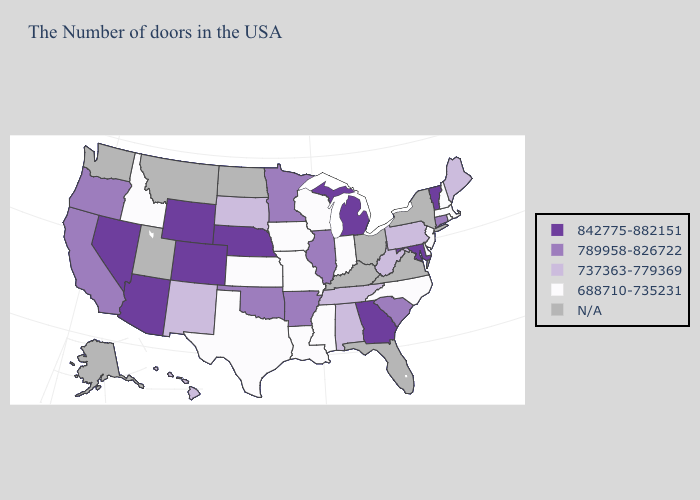What is the highest value in the USA?
Write a very short answer. 842775-882151. Is the legend a continuous bar?
Write a very short answer. No. Does Indiana have the highest value in the MidWest?
Short answer required. No. What is the highest value in the MidWest ?
Short answer required. 842775-882151. Among the states that border Wisconsin , which have the lowest value?
Be succinct. Iowa. Among the states that border California , does Oregon have the lowest value?
Keep it brief. Yes. What is the value of Rhode Island?
Keep it brief. 688710-735231. Name the states that have a value in the range 842775-882151?
Write a very short answer. Vermont, Maryland, Georgia, Michigan, Nebraska, Wyoming, Colorado, Arizona, Nevada. Does South Carolina have the lowest value in the USA?
Give a very brief answer. No. Does Vermont have the highest value in the USA?
Be succinct. Yes. What is the highest value in the USA?
Be succinct. 842775-882151. What is the lowest value in the West?
Write a very short answer. 688710-735231. Among the states that border Kansas , which have the highest value?
Concise answer only. Nebraska, Colorado. 